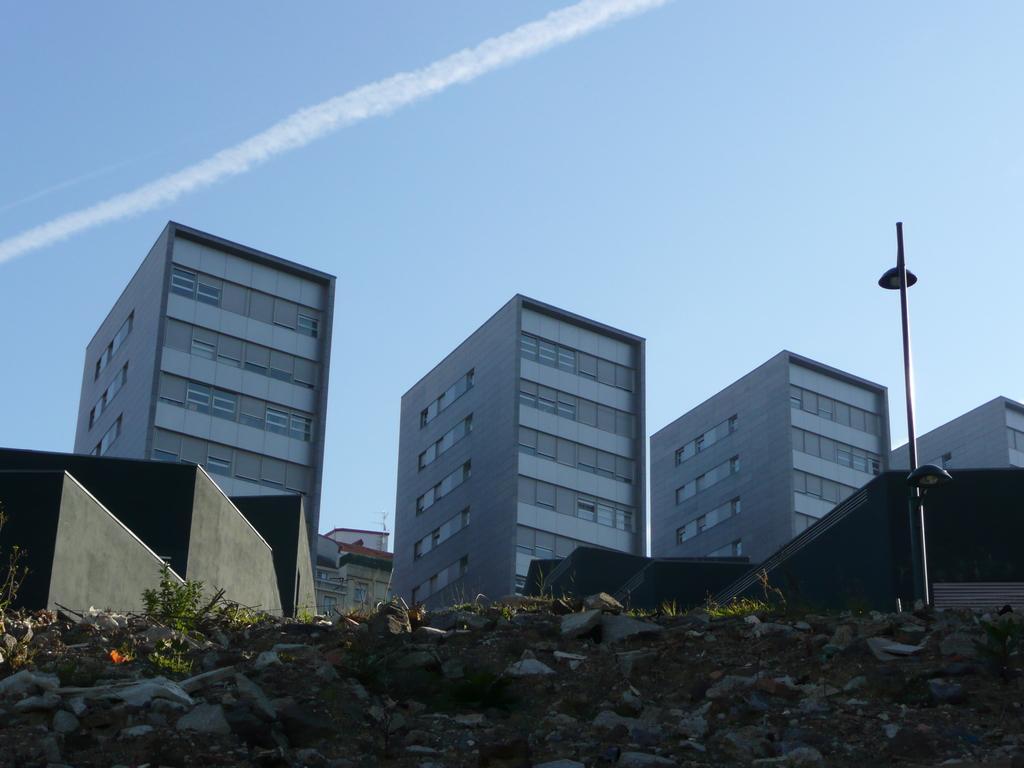Please provide a concise description of this image. In this image I can see the ground, few plants, few rocks and a pole. In the background I can see few buildings and the sky. 